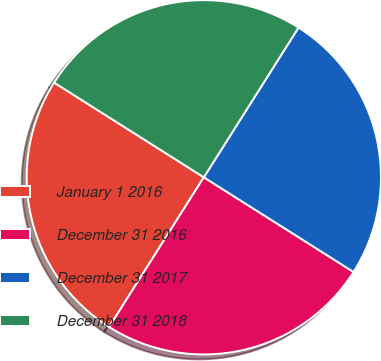Convert chart to OTSL. <chart><loc_0><loc_0><loc_500><loc_500><pie_chart><fcel>January 1 2016<fcel>December 31 2016<fcel>December 31 2017<fcel>December 31 2018<nl><fcel>25.0%<fcel>25.0%<fcel>25.0%<fcel>25.0%<nl></chart> 